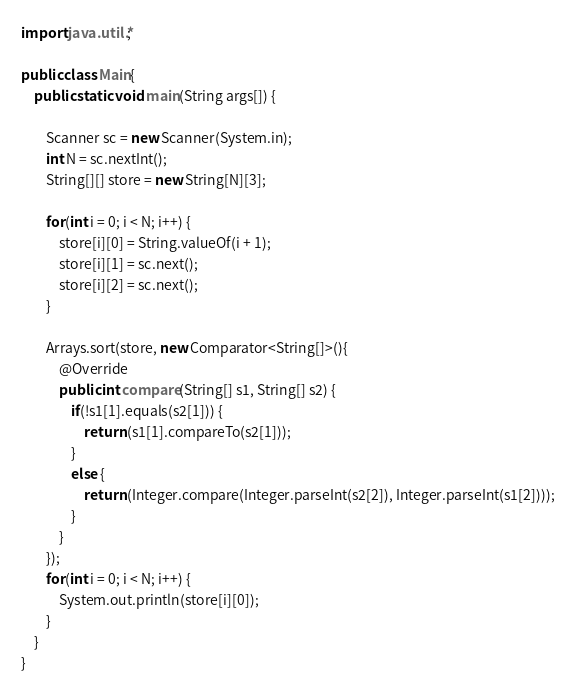Convert code to text. <code><loc_0><loc_0><loc_500><loc_500><_Java_>import java.util.*;

public class Main{
	public static void main(String args[]) {

		Scanner sc = new Scanner(System.in);
		int N = sc.nextInt();
		String[][] store = new String[N][3];

		for(int i = 0; i < N; i++) {
			store[i][0] = String.valueOf(i + 1);
			store[i][1] = sc.next();
			store[i][2] = sc.next();
		}

		Arrays.sort(store, new Comparator<String[]>(){
			@Override
			public int compare(String[] s1, String[] s2) {
				if(!s1[1].equals(s2[1])) {
					return (s1[1].compareTo(s2[1]));
				}
				else {
					return (Integer.compare(Integer.parseInt(s2[2]), Integer.parseInt(s1[2])));
				}
			}
		});
		for(int i = 0; i < N; i++) {
			System.out.println(store[i][0]);
		}
	}
}</code> 